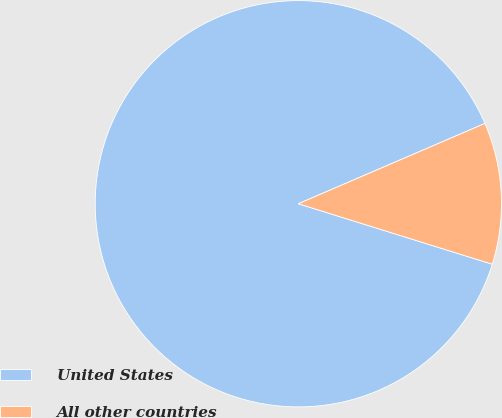<chart> <loc_0><loc_0><loc_500><loc_500><pie_chart><fcel>United States<fcel>All other countries<nl><fcel>88.72%<fcel>11.28%<nl></chart> 